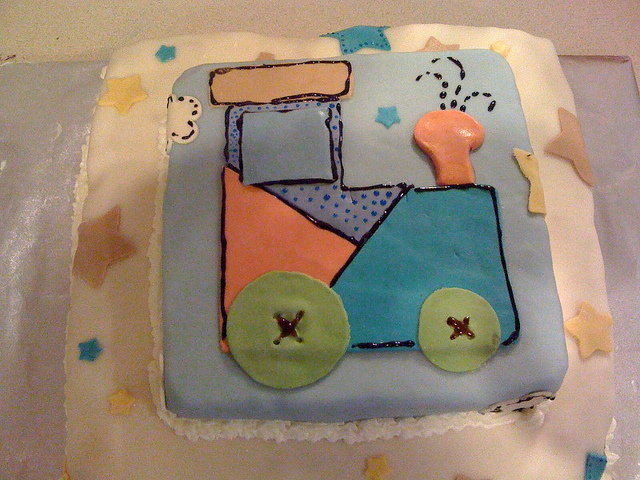<image>What is from space on this cake? I am not sure what is from space on this cake. It can be stars. What is from space on this cake? I am not sure what is from space on this cake. It can be seen stars. 